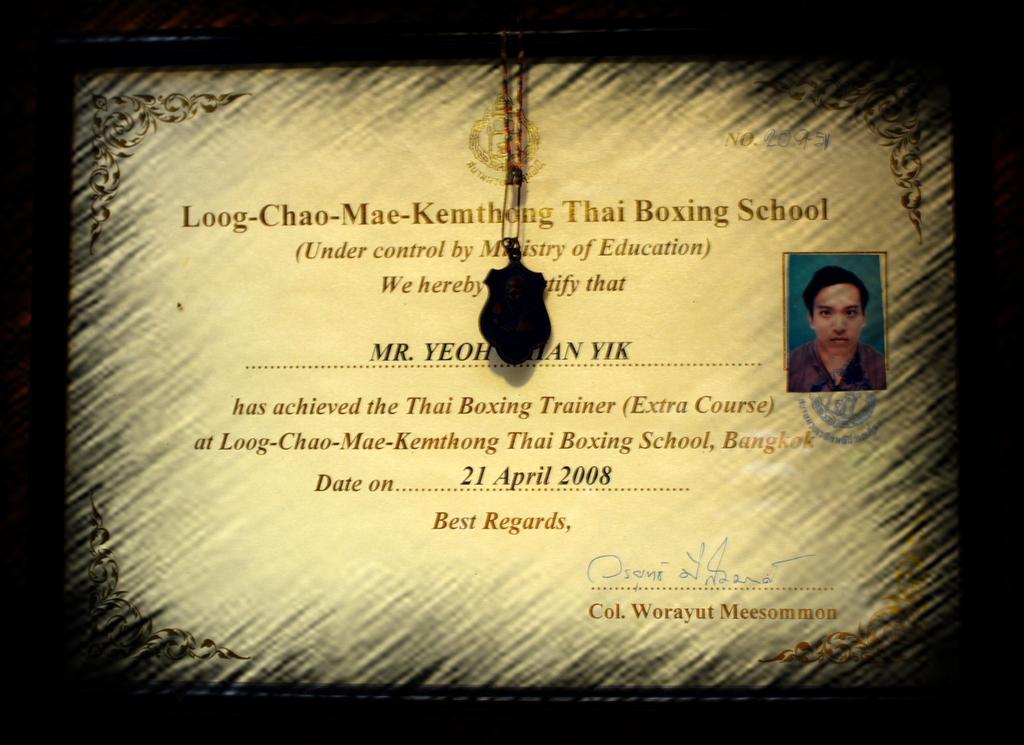Please provide a concise description of this image. In this image we can see a frame containing some text, a photo of a person and a locket. 